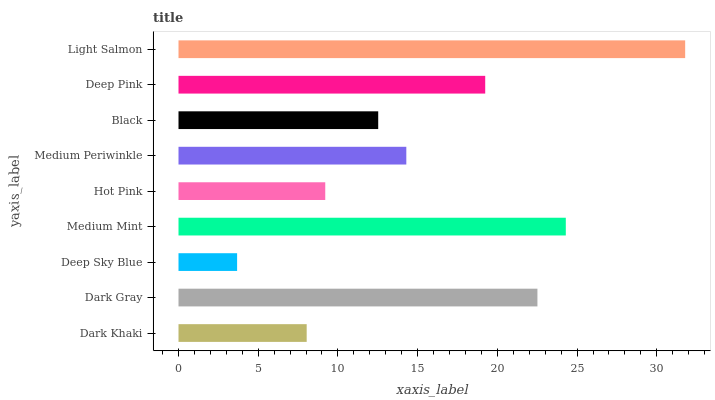Is Deep Sky Blue the minimum?
Answer yes or no. Yes. Is Light Salmon the maximum?
Answer yes or no. Yes. Is Dark Gray the minimum?
Answer yes or no. No. Is Dark Gray the maximum?
Answer yes or no. No. Is Dark Gray greater than Dark Khaki?
Answer yes or no. Yes. Is Dark Khaki less than Dark Gray?
Answer yes or no. Yes. Is Dark Khaki greater than Dark Gray?
Answer yes or no. No. Is Dark Gray less than Dark Khaki?
Answer yes or no. No. Is Medium Periwinkle the high median?
Answer yes or no. Yes. Is Medium Periwinkle the low median?
Answer yes or no. Yes. Is Medium Mint the high median?
Answer yes or no. No. Is Medium Mint the low median?
Answer yes or no. No. 